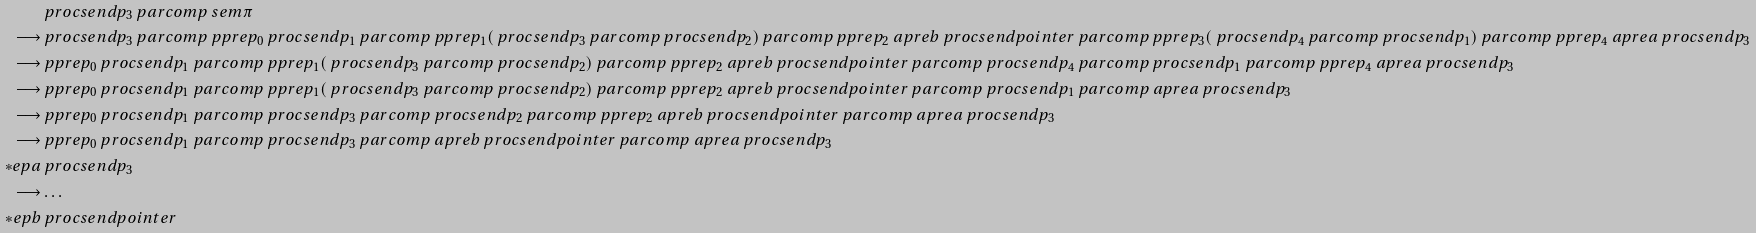Convert formula to latex. <formula><loc_0><loc_0><loc_500><loc_500>& \ p r o c s e n d { p _ { 3 } } \ p a r c o m p \ s e m { \pi } \\ \longrightarrow & \ p r o c s e n d { p _ { 3 } } \ p a r c o m p \ p p r e { p _ { 0 } } \ p r o c s e n d { p _ { 1 } } \ p a r c o m p \ p p r e { p _ { 1 } } ( \ p r o c s e n d { p _ { 3 } } \ p a r c o m p \ p r o c s e n d { p _ { 2 } } ) \ p a r c o m p \ p p r e { p _ { 2 } } \ a p r e { b } \ p r o c s e n d { \null p o i n t e r } \ p a r c o m p \ p p r e { p _ { 3 } } ( \ p r o c s e n d { p _ { 4 } } \ p a r c o m p \ p r o c s e n d { p _ { 1 } } ) \ p a r c o m p \ p p r e { p _ { 4 } } \ a p r e { a } \ p r o c s e n d { p _ { 3 } } \\ \longrightarrow & \ p p r e { p _ { 0 } } \ p r o c s e n d { p _ { 1 } } \ p a r c o m p \ p p r e { p _ { 1 } } ( \ p r o c s e n d { p _ { 3 } } \ p a r c o m p \ p r o c s e n d { p _ { 2 } } ) \ p a r c o m p \ p p r e { p _ { 2 } } \ a p r e { b } \ p r o c s e n d { \null p o i n t e r } \ p a r c o m p \ p r o c s e n d { p _ { 4 } } \ p a r c o m p \ p r o c s e n d { p _ { 1 } } \ p a r c o m p \ p p r e { p _ { 4 } } \ a p r e { a } \ p r o c s e n d { p _ { 3 } } \\ \longrightarrow & \ p p r e { p _ { 0 } } \ p r o c s e n d { p _ { 1 } } \ p a r c o m p \ p p r e { p _ { 1 } } ( \ p r o c s e n d { p _ { 3 } } \ p a r c o m p \ p r o c s e n d { p _ { 2 } } ) \ p a r c o m p \ p p r e { p _ { 2 } } \ a p r e { b } \ p r o c s e n d { \null p o i n t e r } \ p a r c o m p \ p r o c s e n d { p _ { 1 } } \ p a r c o m p \ a p r e { a } \ p r o c s e n d { p _ { 3 } } \\ \longrightarrow & \ p p r e { p _ { 0 } } \ p r o c s e n d { p _ { 1 } } \ p a r c o m p \ p r o c s e n d { p _ { 3 } } \ p a r c o m p \ p r o c s e n d { p _ { 2 } } \ p a r c o m p \ p p r e { p _ { 2 } } \ a p r e { b } \ p r o c s e n d { \null p o i n t e r } \ p a r c o m p \ a p r e { a } \ p r o c s e n d { p _ { 3 } } \\ \longrightarrow & \ p p r e { p _ { 0 } } \ p r o c s e n d { p _ { 1 } } \ p a r c o m p \ p r o c s e n d { p _ { 3 } } \ p a r c o m p \ a p r e { b } \ p r o c s e n d { \null p o i n t e r } \ p a r c o m p \ a p r e { a } \ p r o c s e n d { p _ { 3 } } \\ \ast e p { a } & \ p r o c s e n d { p _ { 3 } } \\ \longrightarrow & \dots \\ \ast e p { b } & \ p r o c s e n d { \null p o i n t e r }</formula> 